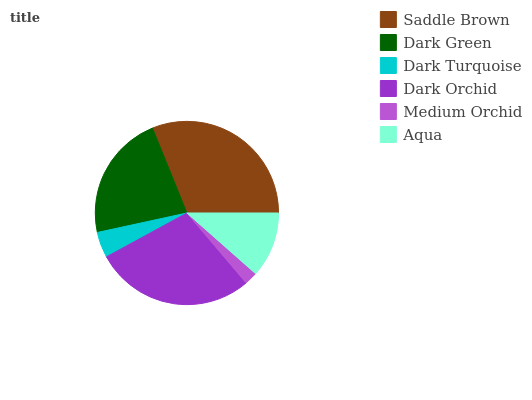Is Medium Orchid the minimum?
Answer yes or no. Yes. Is Saddle Brown the maximum?
Answer yes or no. Yes. Is Dark Green the minimum?
Answer yes or no. No. Is Dark Green the maximum?
Answer yes or no. No. Is Saddle Brown greater than Dark Green?
Answer yes or no. Yes. Is Dark Green less than Saddle Brown?
Answer yes or no. Yes. Is Dark Green greater than Saddle Brown?
Answer yes or no. No. Is Saddle Brown less than Dark Green?
Answer yes or no. No. Is Dark Green the high median?
Answer yes or no. Yes. Is Aqua the low median?
Answer yes or no. Yes. Is Medium Orchid the high median?
Answer yes or no. No. Is Saddle Brown the low median?
Answer yes or no. No. 